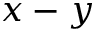Convert formula to latex. <formula><loc_0><loc_0><loc_500><loc_500>x - y</formula> 